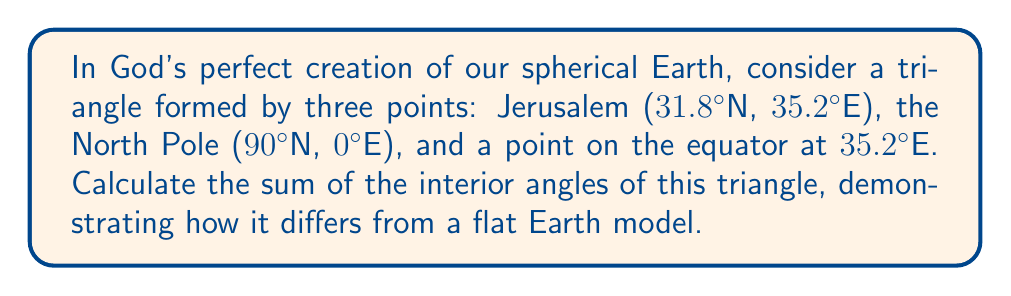What is the answer to this math problem? Let's approach this step-by-step, keeping in mind that on a sphere, the sum of angles in a triangle is always greater than 180°:

1) First, we need to calculate the three angles of our spherical triangle:

   a) The angle at the North Pole (A):
      This is simply the difference in longitude between Jerusalem and the equator point, which is 0°.
      $$A = 35.2° - 35.2° = 0°$$

   b) The angle at Jerusalem (B):
      We can calculate this using the spherical law of cosines:
      $$\cos(b) = \sin(C)\cos(a)$$
      Where b is the colatitude of Jerusalem (90° - 31.8° = 58.2°), C is 90° (the angle at the equator), and a is the colatitude of the North Pole (0°).
      $$\cos(58.2°) = \sin(90°)\cos(0°)$$
      $$\cos(58.2°) = 1 \cdot 1 = 1$$
      $$B = \arccos(0.5299) = 58.2°$$

   c) The angle at the equator point (C):
      This is always 90° for any point on the equator in this configuration.

2) Now, we sum these angles:
   $$0° + 58.2° + 90° = 148.2°$$

3) The excess angle (how much it exceeds 180°) is:
   $$148.2° - 180° = -31.8°$$

4) To get the actual sum, we add this excess to 180°:
   $$180° + 31.8° = 211.8°$$

This result demonstrates that on our God-given spherical Earth, the sum of angles in a triangle exceeds 180°, unlike on a flat surface where it would equal exactly 180°.
Answer: $$211.8°$$ 